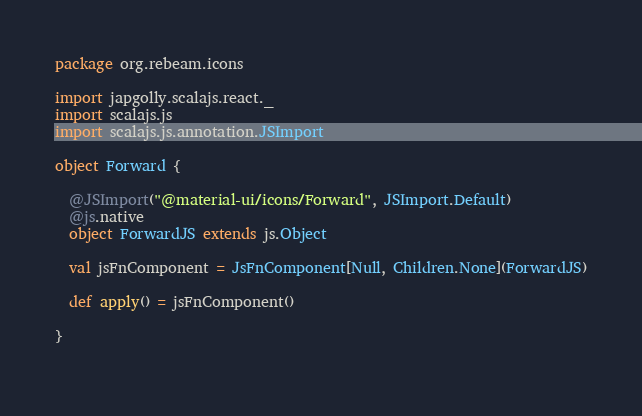Convert code to text. <code><loc_0><loc_0><loc_500><loc_500><_Scala_>
package org.rebeam.icons

import japgolly.scalajs.react._
import scalajs.js
import scalajs.js.annotation.JSImport

object Forward {

  @JSImport("@material-ui/icons/Forward", JSImport.Default)
  @js.native
  object ForwardJS extends js.Object

  val jsFnComponent = JsFnComponent[Null, Children.None](ForwardJS)
  
  def apply() = jsFnComponent()

}
    </code> 